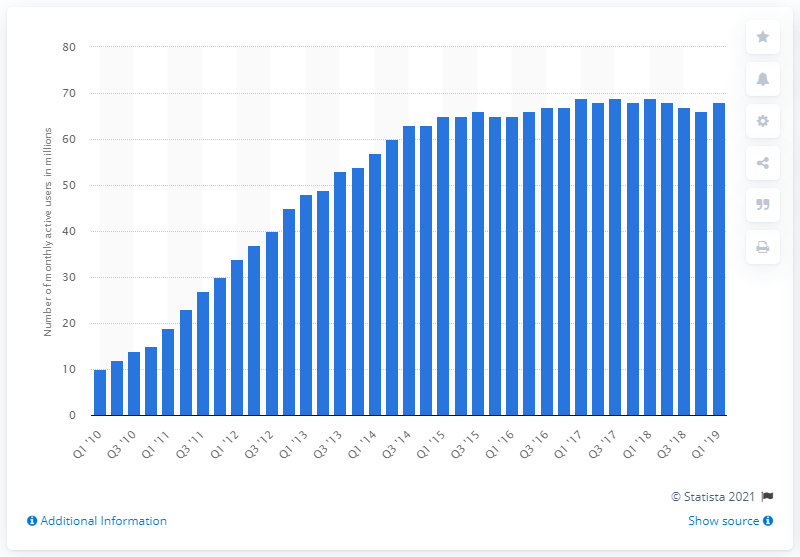Specify some key components in this picture. In the first quarter of 2019, there were approximately 68 monthly active U.S. Twitter users. The growth from the previous quarter was 68.. 